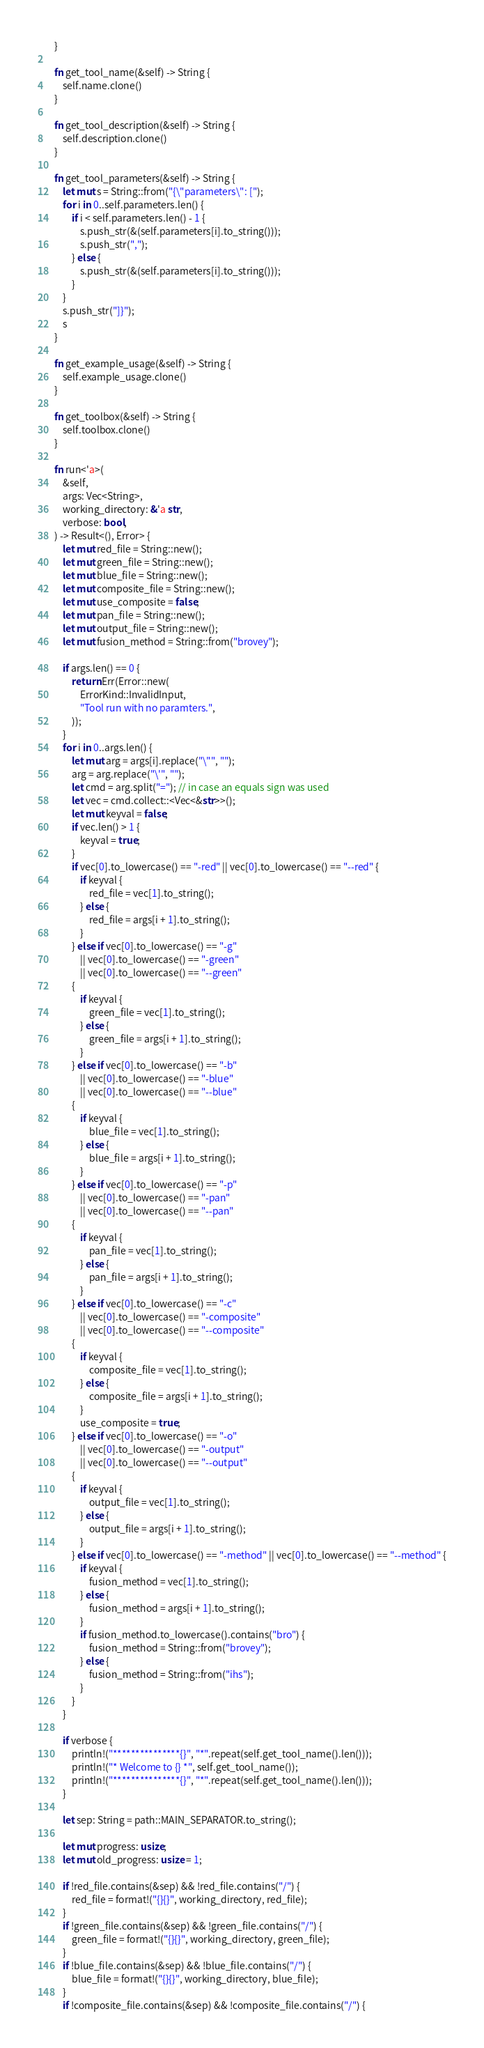Convert code to text. <code><loc_0><loc_0><loc_500><loc_500><_Rust_>    }

    fn get_tool_name(&self) -> String {
        self.name.clone()
    }

    fn get_tool_description(&self) -> String {
        self.description.clone()
    }

    fn get_tool_parameters(&self) -> String {
        let mut s = String::from("{\"parameters\": [");
        for i in 0..self.parameters.len() {
            if i < self.parameters.len() - 1 {
                s.push_str(&(self.parameters[i].to_string()));
                s.push_str(",");
            } else {
                s.push_str(&(self.parameters[i].to_string()));
            }
        }
        s.push_str("]}");
        s
    }

    fn get_example_usage(&self) -> String {
        self.example_usage.clone()
    }

    fn get_toolbox(&self) -> String {
        self.toolbox.clone()
    }

    fn run<'a>(
        &self,
        args: Vec<String>,
        working_directory: &'a str,
        verbose: bool,
    ) -> Result<(), Error> {
        let mut red_file = String::new();
        let mut green_file = String::new();
        let mut blue_file = String::new();
        let mut composite_file = String::new();
        let mut use_composite = false;
        let mut pan_file = String::new();
        let mut output_file = String::new();
        let mut fusion_method = String::from("brovey");

        if args.len() == 0 {
            return Err(Error::new(
                ErrorKind::InvalidInput,
                "Tool run with no paramters.",
            ));
        }
        for i in 0..args.len() {
            let mut arg = args[i].replace("\"", "");
            arg = arg.replace("\'", "");
            let cmd = arg.split("="); // in case an equals sign was used
            let vec = cmd.collect::<Vec<&str>>();
            let mut keyval = false;
            if vec.len() > 1 {
                keyval = true;
            }
            if vec[0].to_lowercase() == "-red" || vec[0].to_lowercase() == "--red" {
                if keyval {
                    red_file = vec[1].to_string();
                } else {
                    red_file = args[i + 1].to_string();
                }
            } else if vec[0].to_lowercase() == "-g"
                || vec[0].to_lowercase() == "-green"
                || vec[0].to_lowercase() == "--green"
            {
                if keyval {
                    green_file = vec[1].to_string();
                } else {
                    green_file = args[i + 1].to_string();
                }
            } else if vec[0].to_lowercase() == "-b"
                || vec[0].to_lowercase() == "-blue"
                || vec[0].to_lowercase() == "--blue"
            {
                if keyval {
                    blue_file = vec[1].to_string();
                } else {
                    blue_file = args[i + 1].to_string();
                }
            } else if vec[0].to_lowercase() == "-p"
                || vec[0].to_lowercase() == "-pan"
                || vec[0].to_lowercase() == "--pan"
            {
                if keyval {
                    pan_file = vec[1].to_string();
                } else {
                    pan_file = args[i + 1].to_string();
                }
            } else if vec[0].to_lowercase() == "-c"
                || vec[0].to_lowercase() == "-composite"
                || vec[0].to_lowercase() == "--composite"
            {
                if keyval {
                    composite_file = vec[1].to_string();
                } else {
                    composite_file = args[i + 1].to_string();
                }
                use_composite = true;
            } else if vec[0].to_lowercase() == "-o"
                || vec[0].to_lowercase() == "-output"
                || vec[0].to_lowercase() == "--output"
            {
                if keyval {
                    output_file = vec[1].to_string();
                } else {
                    output_file = args[i + 1].to_string();
                }
            } else if vec[0].to_lowercase() == "-method" || vec[0].to_lowercase() == "--method" {
                if keyval {
                    fusion_method = vec[1].to_string();
                } else {
                    fusion_method = args[i + 1].to_string();
                }
                if fusion_method.to_lowercase().contains("bro") {
                    fusion_method = String::from("brovey");
                } else {
                    fusion_method = String::from("ihs");
                }
            }
        }

        if verbose {
            println!("***************{}", "*".repeat(self.get_tool_name().len()));
            println!("* Welcome to {} *", self.get_tool_name());
            println!("***************{}", "*".repeat(self.get_tool_name().len()));
        }

        let sep: String = path::MAIN_SEPARATOR.to_string();

        let mut progress: usize;
        let mut old_progress: usize = 1;

        if !red_file.contains(&sep) && !red_file.contains("/") {
            red_file = format!("{}{}", working_directory, red_file);
        }
        if !green_file.contains(&sep) && !green_file.contains("/") {
            green_file = format!("{}{}", working_directory, green_file);
        }
        if !blue_file.contains(&sep) && !blue_file.contains("/") {
            blue_file = format!("{}{}", working_directory, blue_file);
        }
        if !composite_file.contains(&sep) && !composite_file.contains("/") {</code> 